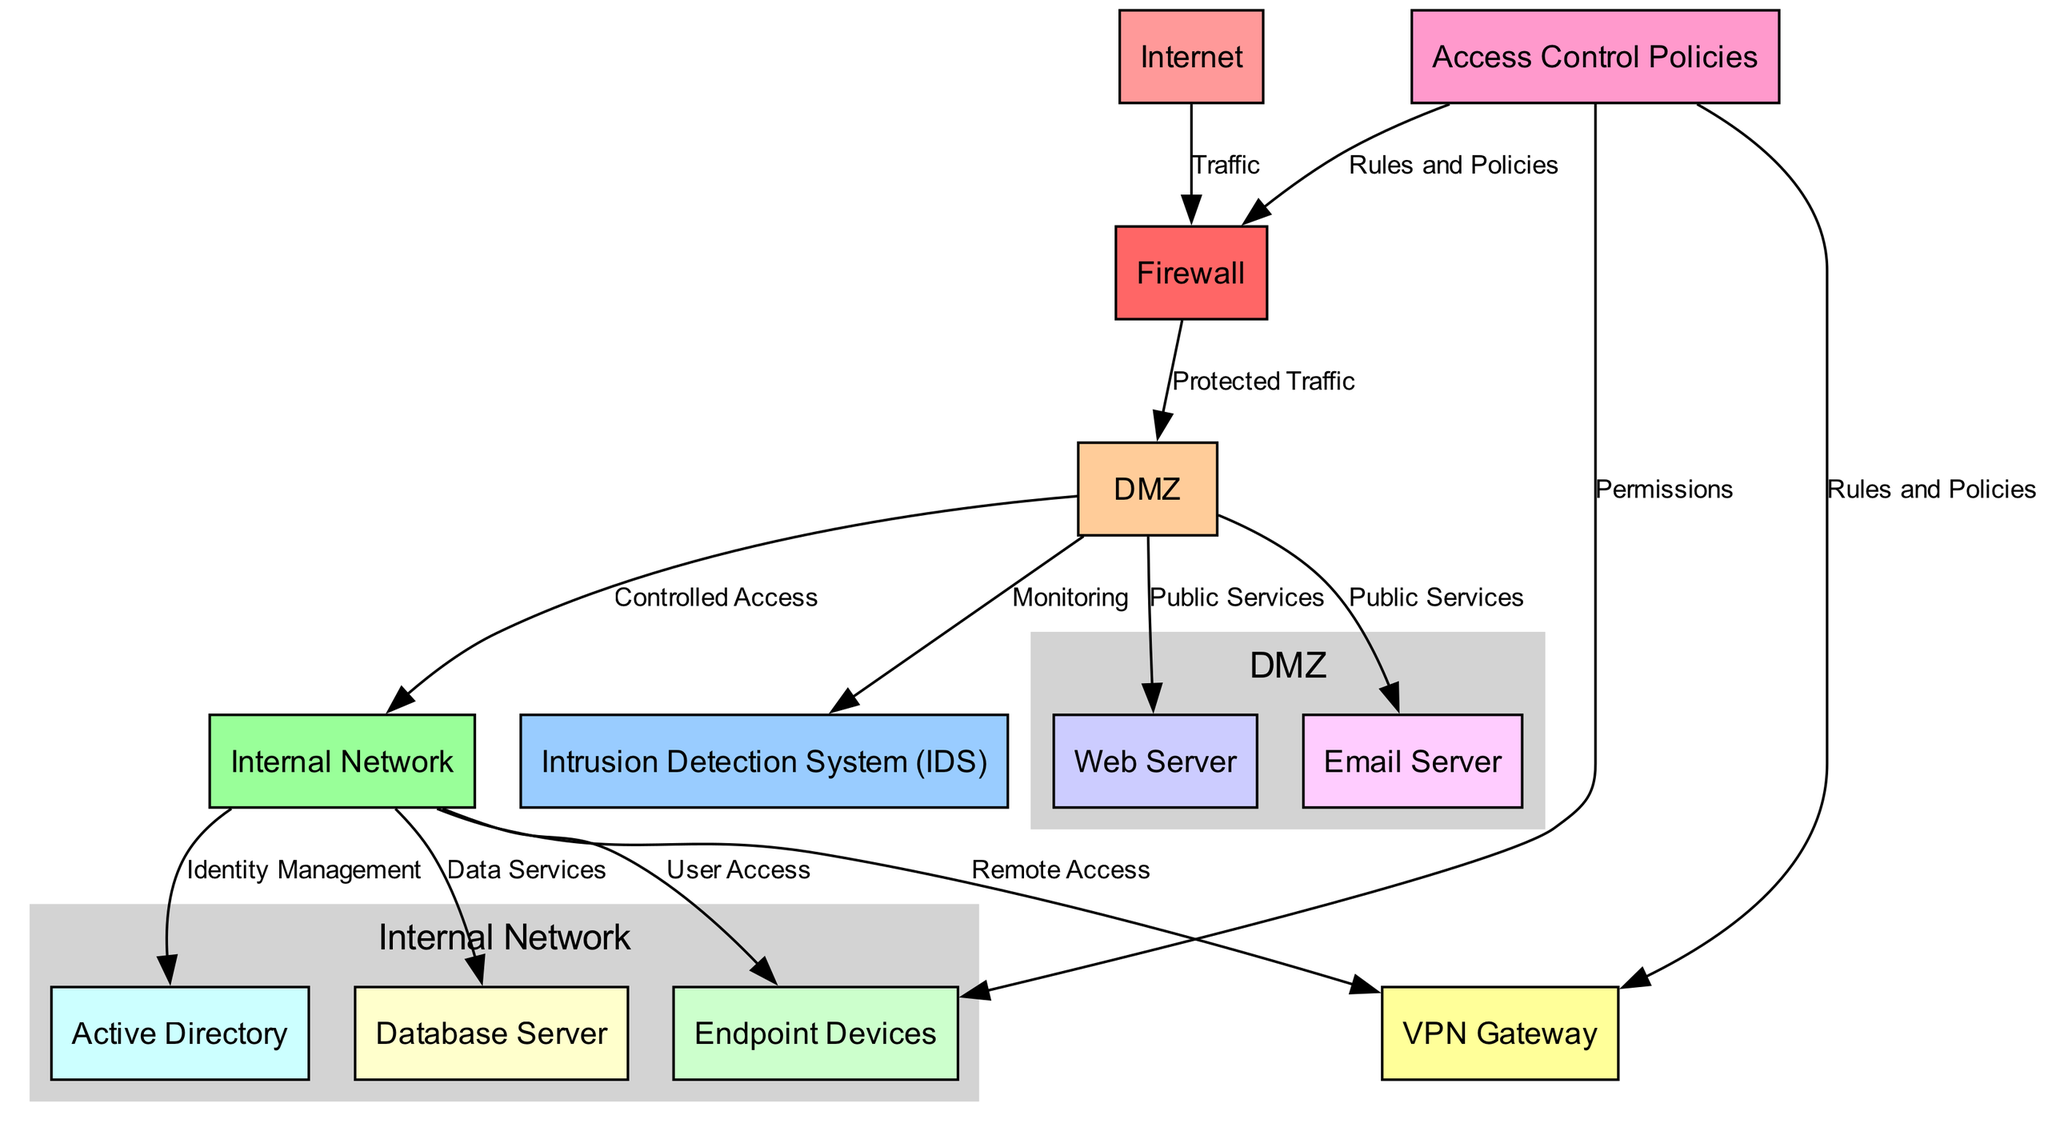What is the primary function of the firewall node? The function of the firewall is to filter traffic coming from the internet and control access to the DMZ, ensuring only protected traffic reaches the DMZ components.
Answer: Filter traffic How many nodes are present in the diagram? By counting each node listed under "nodes," we identify a total of 12 distinct nodes representing various components of the network security architecture.
Answer: 12 Which node is connected directly to the IDS? The IDS is directly connected to the DMZ, indicated by an edge labeled “Monitoring,” which shows that it monitors the traffic flow in the DMZ.
Answer: DMZ What type of network devices do the endpoint devices connect to in the internal network? The endpoint devices connect to the internal network, which provides user access, as indicated by the edge labeled “User Access.”
Answer: Internal Network How does the Internet connect to the firewall? The Internet connects to the firewall through a directed edge labeled “Traffic,” indicating that traffic flows towards the firewall from the Internet.
Answer: Traffic What is the purpose of the access control policies in this diagram? The access control policies define the rules and permissions for various network components, controlling what traffic can pass through the firewall and access the VPN and endpoint devices.
Answer: Rules and Permissions How many edges connect the DMZ to other components? The DMZ has four edges connecting it to the web server, email server, IDS, and internal network, indicating multiple relationships with other components.
Answer: 4 Which component allows for remote access to the internal network? The VPN Gateway allows for remote access to the internal network, as shown by the edge labeled “Remote Access.”
Answer: VPN Gateway What nodes represent public services in the DMZ? The nodes that represent public services in the DMZ are the web server and email server, directly linked to the DMZ node.
Answer: Web Server, Email Server Which node is responsible for identity management? The Active Directory node is responsible for identity management in this architecture, connecting to the internal network to manage identities and access.
Answer: Active Directory 